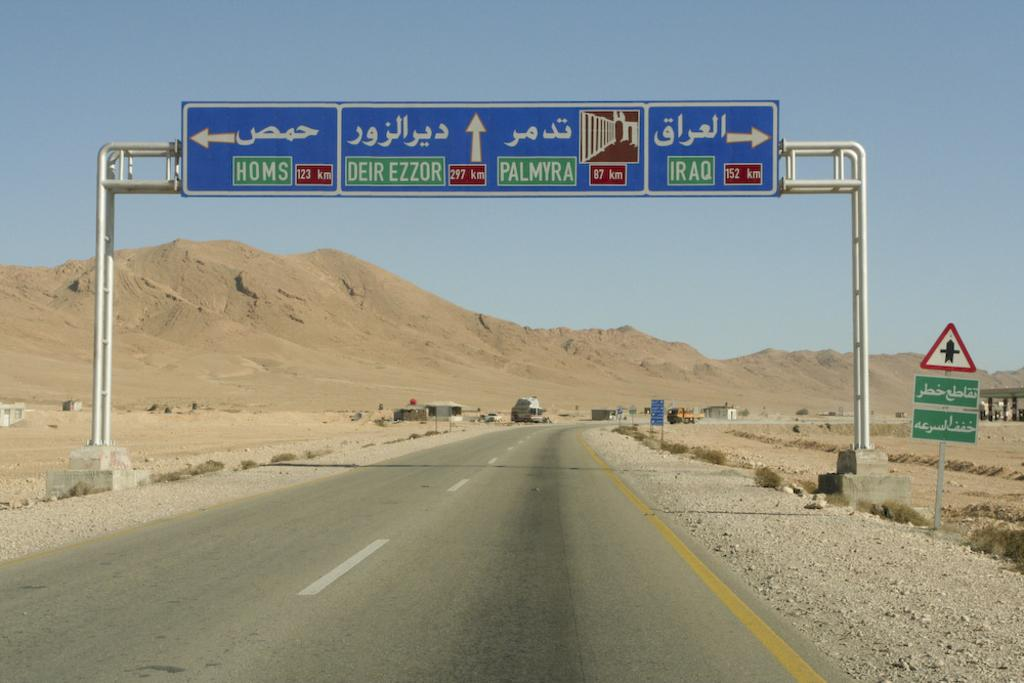Provide a one-sentence caption for the provided image. A highway sign points toward locations like Palmyra, Iraq and Homs. 